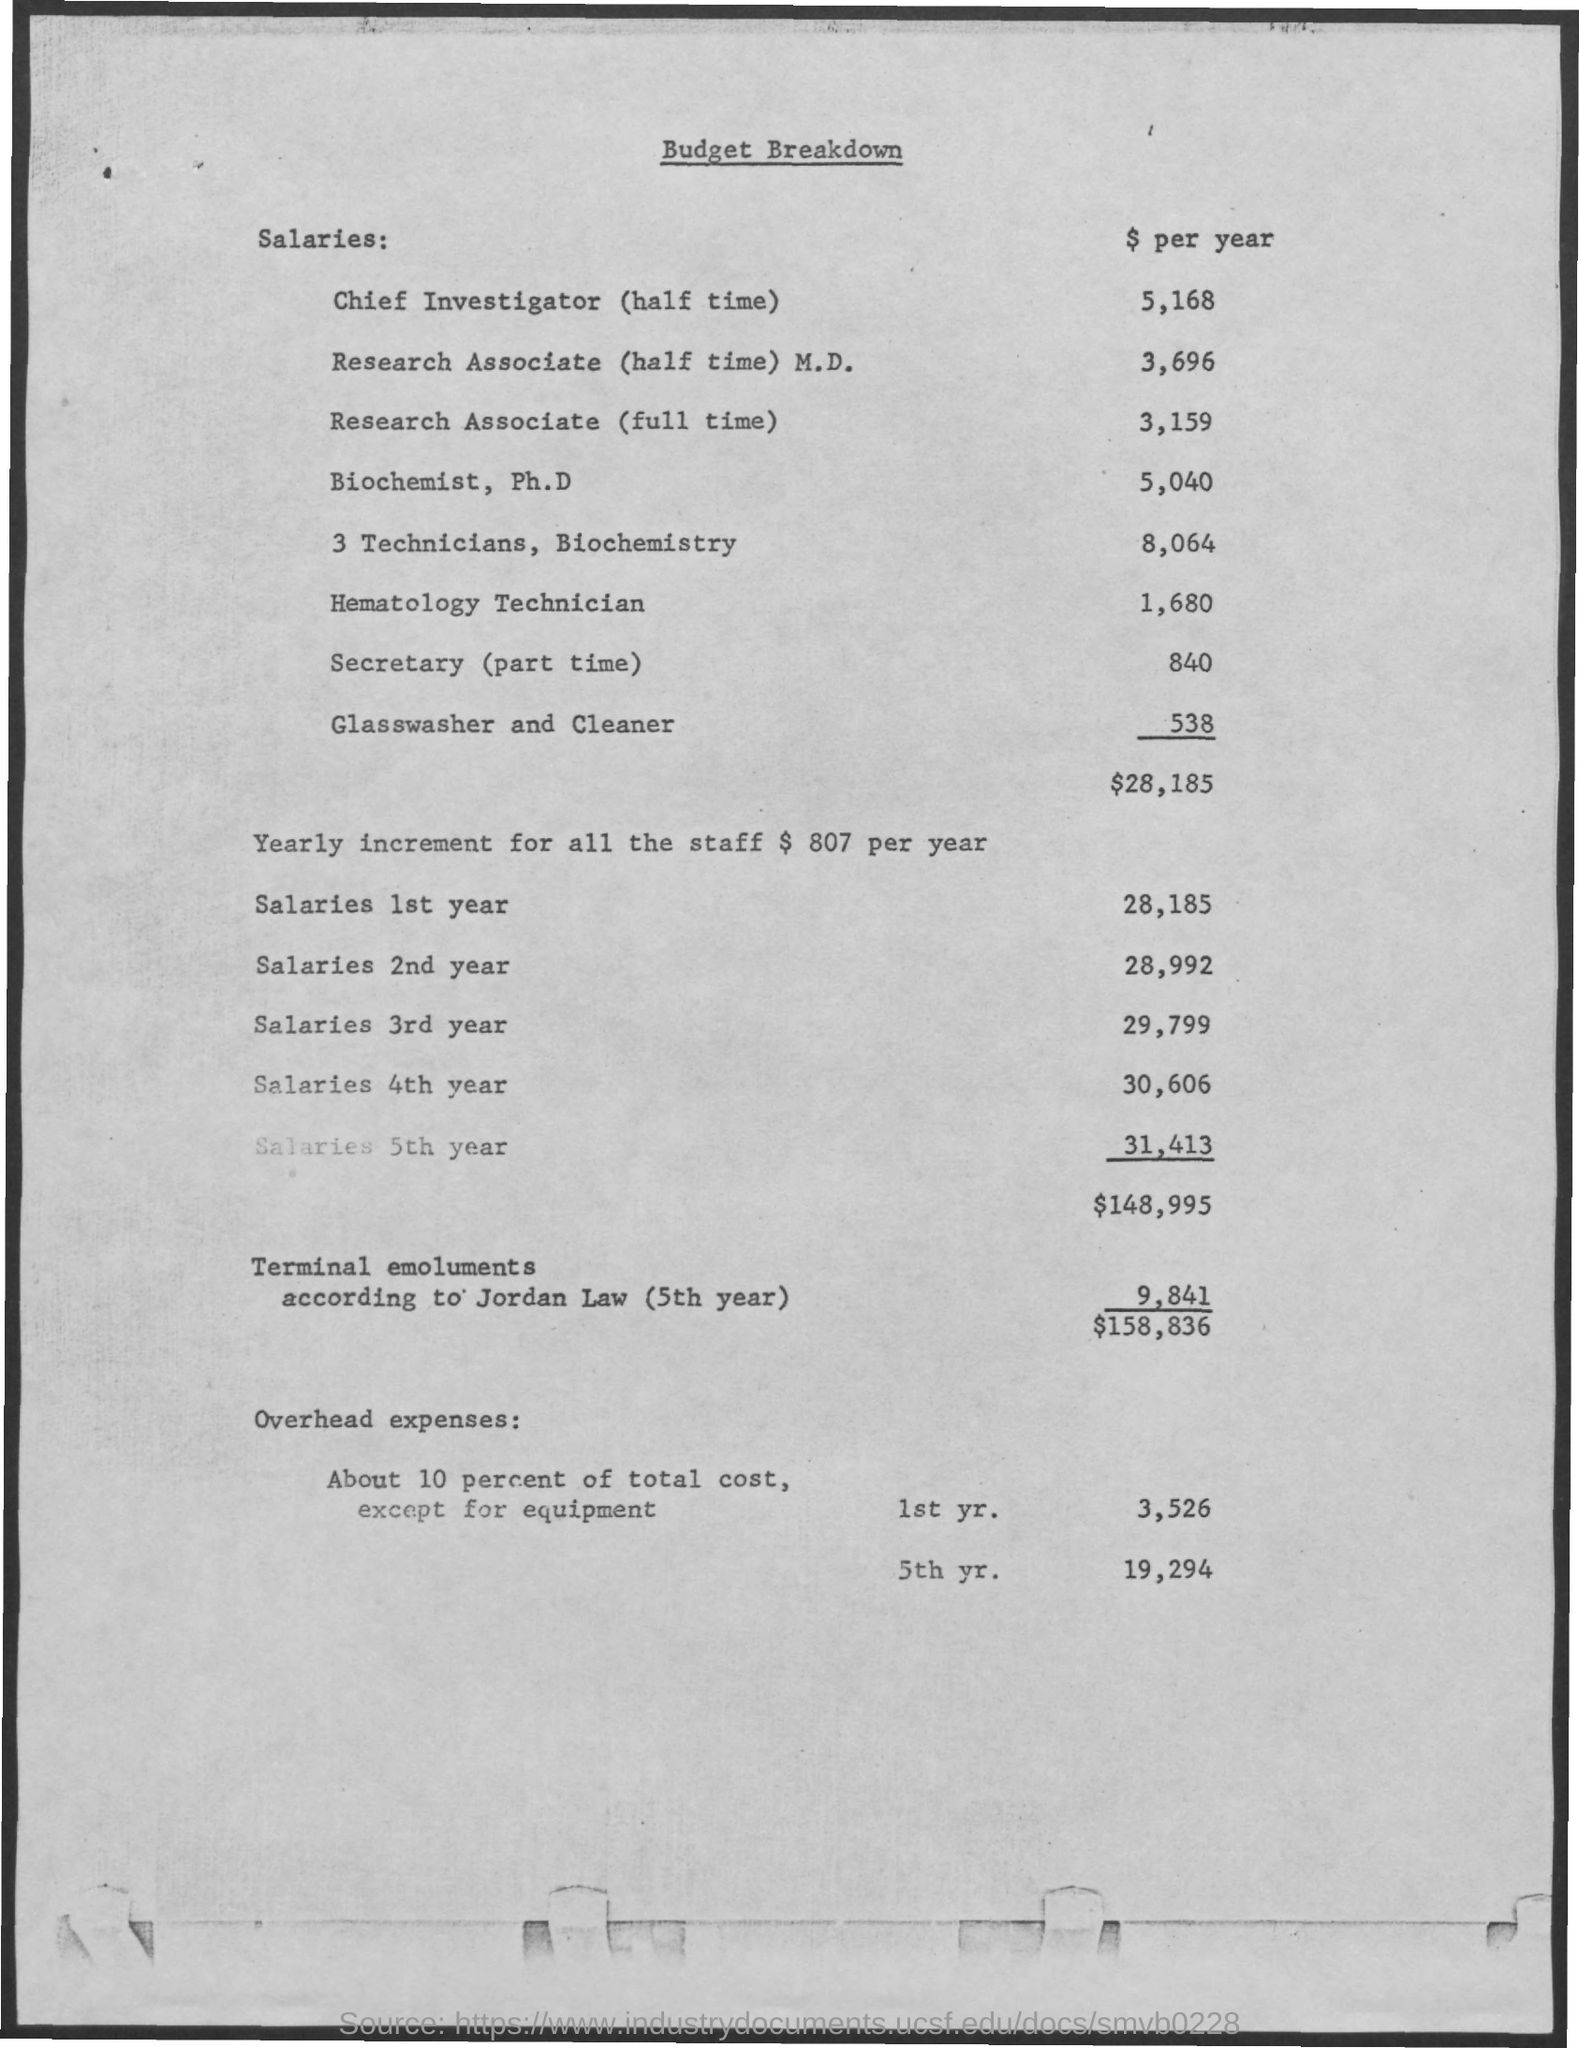Outline some significant characteristics in this image. This document is about the budget breakdown for a particular topic. The total of the salaries for all five years is $148,995. The total salaries for the first year is 28,185. The salary of a secretary is approximately $840 per year. 